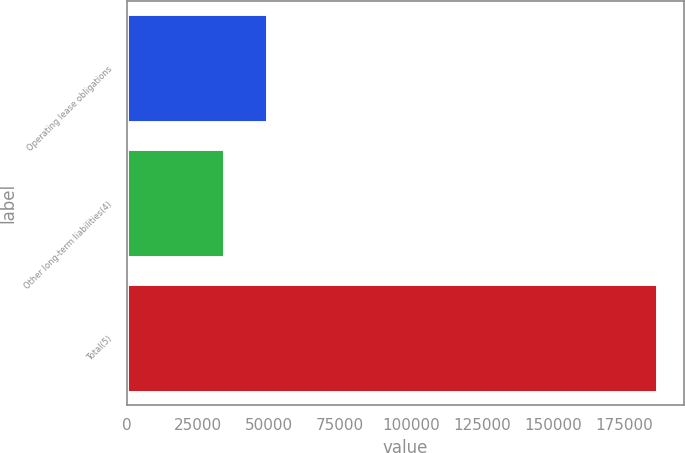Convert chart. <chart><loc_0><loc_0><loc_500><loc_500><bar_chart><fcel>Operating lease obligations<fcel>Other long-term liabilities(4)<fcel>Total(5)<nl><fcel>49458.3<fcel>34199<fcel>186792<nl></chart> 